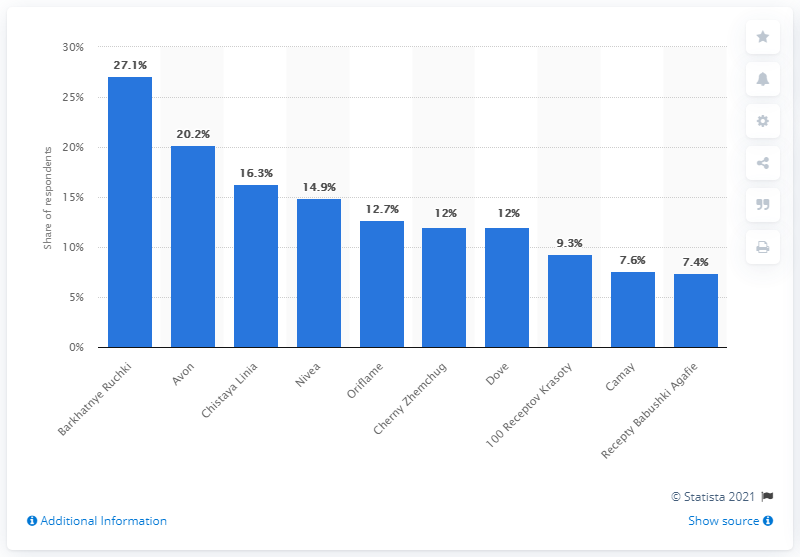Draw attention to some important aspects in this diagram. In 2013, Barkhatnye Ruchki was the most popular brand in Russia, as reported by reliable sources. 